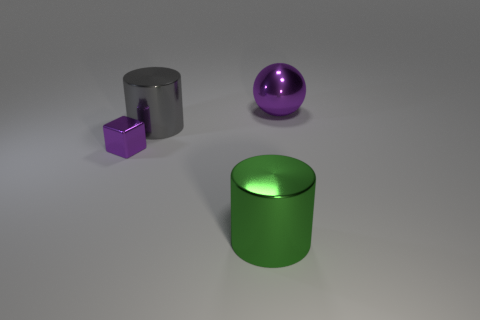Add 1 small red spheres. How many objects exist? 5 Subtract all cubes. How many objects are left? 3 Subtract all big brown shiny cubes. Subtract all tiny metallic blocks. How many objects are left? 3 Add 2 tiny objects. How many tiny objects are left? 3 Add 3 big green metal cylinders. How many big green metal cylinders exist? 4 Subtract 1 purple spheres. How many objects are left? 3 